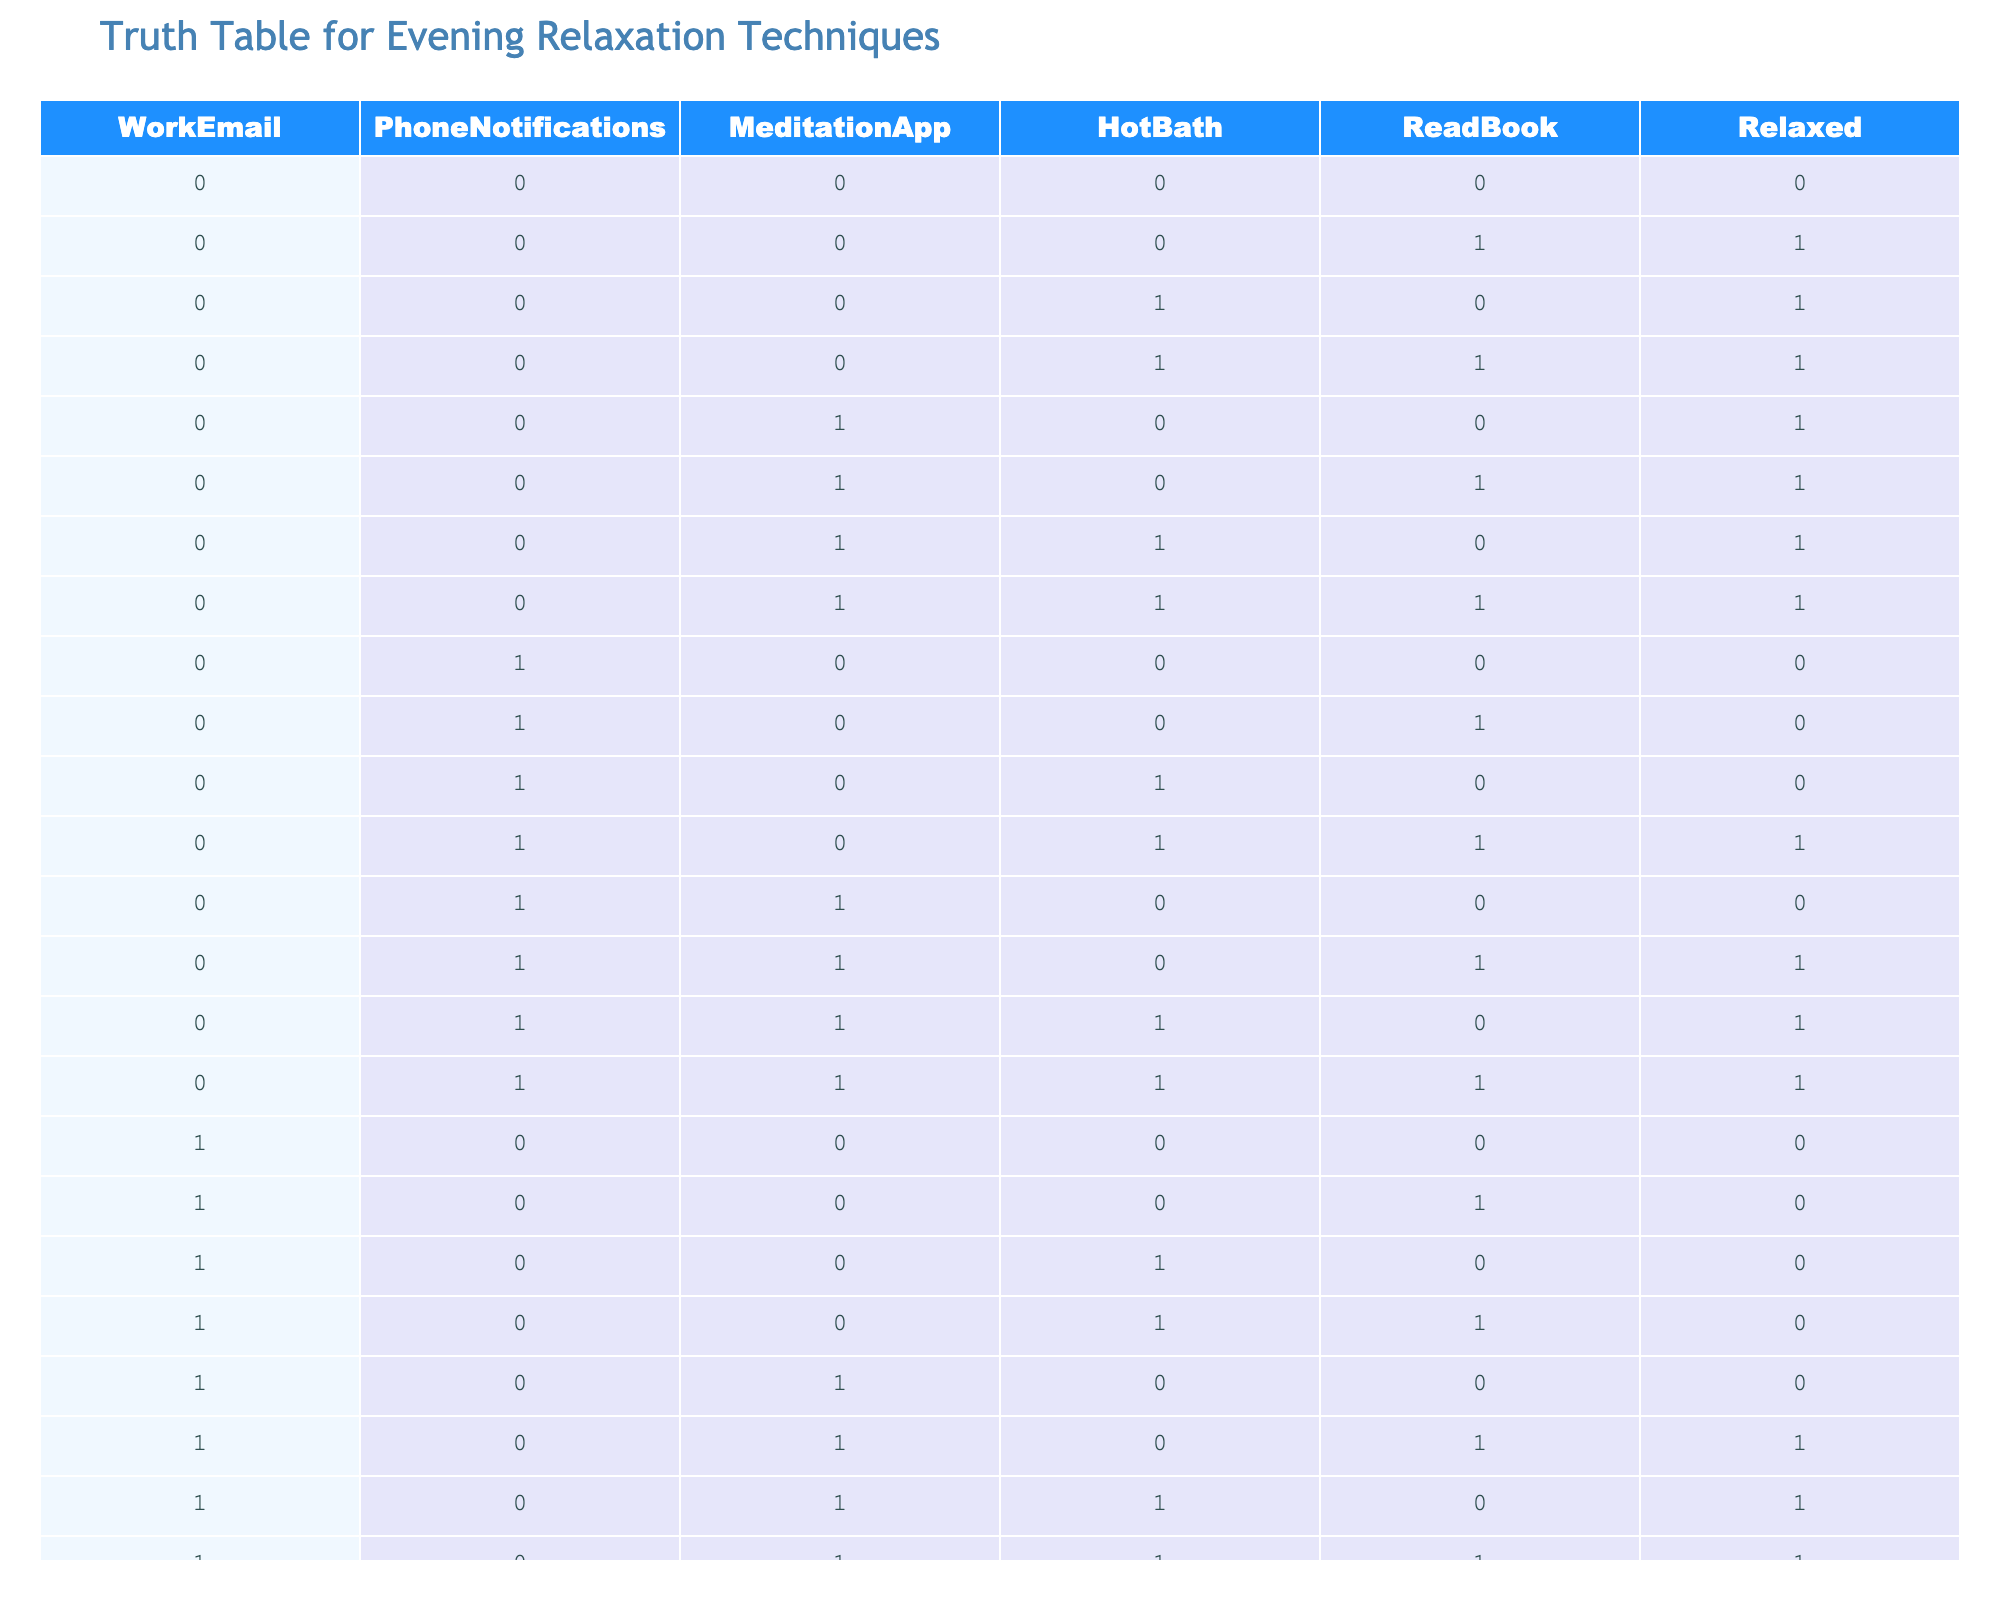What is the value of 'Relaxed' when no evening activities are done? In the table, when all evening activities (WorkEmail, PhoneNotifications, MeditationApp, HotBath, ReadBook) are 0, the value for 'Relaxed' is 0.
Answer: 0 How many times does meditation contribute to relaxation? When the MeditationApp is used (value 1), there are 8 instances (rows) where 'Relaxed' is 1. So, it contributes to relaxation in 8 instances.
Answer: 8 Is it true that taking a hot bath guarantees relaxation? Looking at the table, when HotBath is 1, 'Relaxed' varies; it is 1 in 4 instances and 0 in 2 instances. Hence, it's false that taking a hot bath guarantees relaxation.
Answer: No What is the average value of 'Relaxed' when WorkEmail is not checked? There are 14 rows where WorkEmail = 0, and the sum of 'Relaxed' values in those rows is 11 (1+1+1+1+1+1+1+1+0+0+0+1+0+0). The average is 11/14, which is approximately 0.79.
Answer: 0.79 How does adding reading a book impact the likelihood of feeling relaxed? In cases where ReadBook = 1, 'Relaxed' is 1 in 6 out of 14 instances. When ReadBook = 0, it's 5 out of 14. Therefore, reading positively influences relaxation, but not dramatically.
Answer: ReadBook influences positively How many combinations of all techniques lead to feeling relaxed? There are 12 out of the total 32 combinations (rows) in the table that result in 'Relaxed' = 1. This means various combinations of techniques indeed lead to relaxation.
Answer: 12 What is the outcome for relaxation when both WorkEmail and PhoneNotifications are active? Observing the table, with both WorkEmail and PhoneNotifications active (1s), 'Relaxed' is 0 for 9 combinations. The presence of notifications seems to hinder relaxation.
Answer: 0 If someone takes a hot bath and reads a book, are they guaranteed to feel relaxed? Out of the combinations where HotBath = 1 and ReadBook = 1 (5 instances), there are 3 cases where 'Relaxed' = 1 and 2 where it is 0. Thus, while they're more likely to relax, it's not guaranteed.
Answer: No 